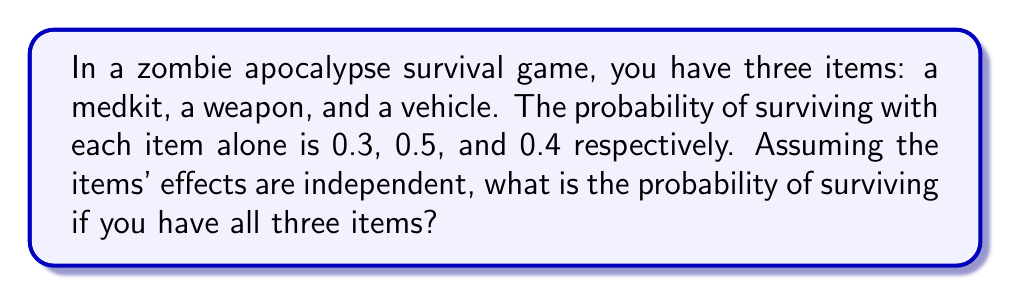Give your solution to this math problem. Let's approach this step-by-step:

1) First, we need to understand what "independent" means in this context. It means that the effect of each item on survival doesn't influence the others.

2) We're looking for the probability of surviving with all three items. This is equivalent to not failing with any of the items.

3) To calculate this, we can use the complement rule. We'll find the probability of not surviving and subtract it from 1.

4) The probability of not surviving with each item:
   Medkit: $1 - 0.3 = 0.7$
   Weapon: $1 - 0.5 = 0.5$
   Vehicle: $1 - 0.4 = 0.6$

5) Since the items are independent, we multiply these probabilities to get the chance of not surviving with any of them:

   $P(\text{not surviving}) = 0.7 \times 0.5 \times 0.6 = 0.21$

6) Now, we can use the complement rule to find the probability of surviving:

   $P(\text{surviving}) = 1 - P(\text{not surviving}) = 1 - 0.21 = 0.79$

7) Therefore, the probability of surviving with all three items is 0.79 or 79%.
Answer: 0.79 